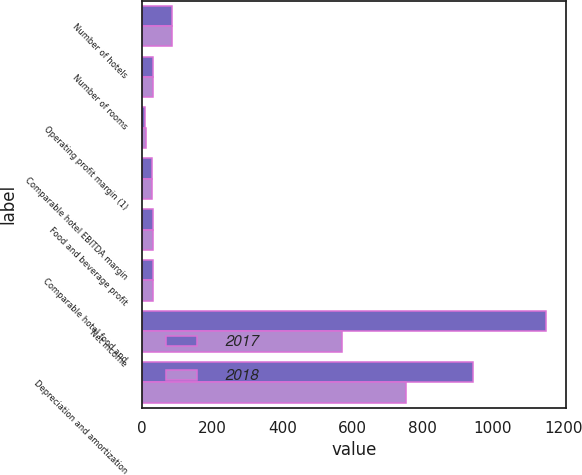Convert chart to OTSL. <chart><loc_0><loc_0><loc_500><loc_500><stacked_bar_chart><ecel><fcel>Number of hotels<fcel>Number of rooms<fcel>Operating profit margin (1)<fcel>Comparable hotel EBITDA margin<fcel>Food and beverage profit<fcel>Comparable hotel food and<fcel>Net income<fcel>Depreciation and amortization<nl><fcel>2017<fcel>85<fcel>32.65<fcel>9.6<fcel>28.8<fcel>31.7<fcel>32.9<fcel>1151<fcel>944<nl><fcel>2018<fcel>85<fcel>32.65<fcel>12.5<fcel>28.2<fcel>31.4<fcel>32.4<fcel>571<fcel>751<nl></chart> 